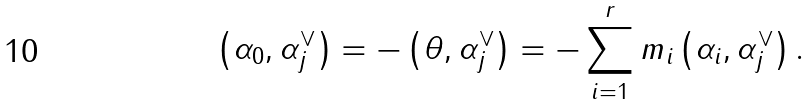Convert formula to latex. <formula><loc_0><loc_0><loc_500><loc_500>\left ( \alpha _ { 0 } , \alpha _ { j } ^ { \vee } \right ) = - \left ( \theta , \alpha _ { j } ^ { \vee } \right ) = - \sum _ { i = 1 } ^ { r } m _ { i } \left ( \alpha _ { i } , \alpha _ { j } ^ { \vee } \right ) .</formula> 